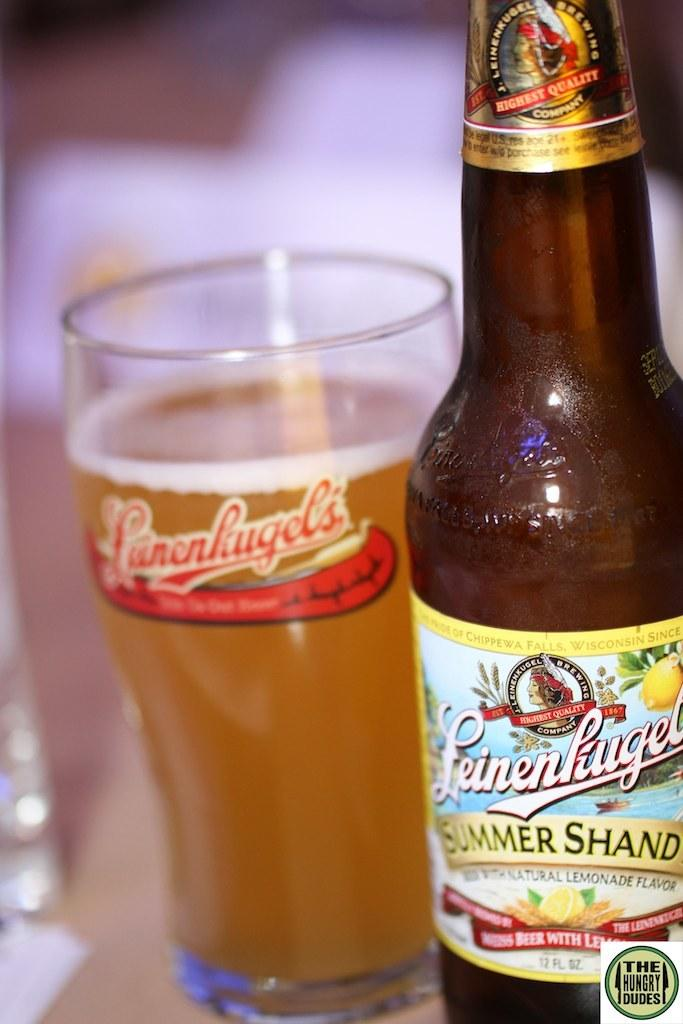<image>
Render a clear and concise summary of the photo. A bottle of Leinenliugel next to a glass of beer. 